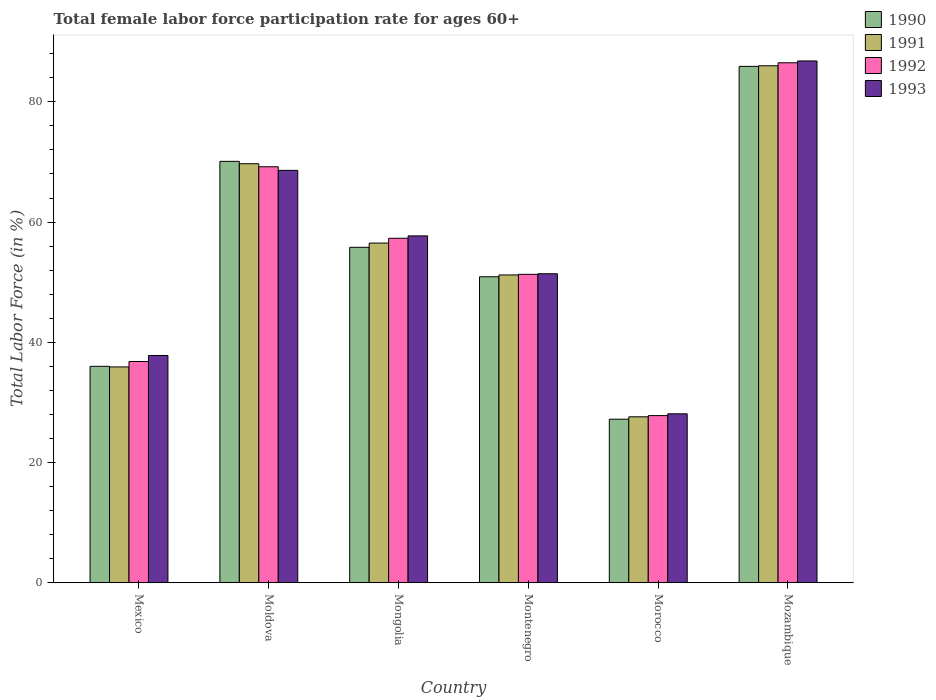How many different coloured bars are there?
Provide a succinct answer. 4. How many groups of bars are there?
Your answer should be very brief. 6. How many bars are there on the 5th tick from the left?
Keep it short and to the point. 4. What is the label of the 4th group of bars from the left?
Give a very brief answer. Montenegro. In how many cases, is the number of bars for a given country not equal to the number of legend labels?
Provide a short and direct response. 0. What is the female labor force participation rate in 1992 in Morocco?
Provide a succinct answer. 27.8. Across all countries, what is the maximum female labor force participation rate in 1990?
Your answer should be compact. 85.9. Across all countries, what is the minimum female labor force participation rate in 1990?
Provide a succinct answer. 27.2. In which country was the female labor force participation rate in 1991 maximum?
Offer a terse response. Mozambique. In which country was the female labor force participation rate in 1990 minimum?
Keep it short and to the point. Morocco. What is the total female labor force participation rate in 1993 in the graph?
Your answer should be compact. 330.4. What is the difference between the female labor force participation rate in 1993 in Moldova and that in Mongolia?
Your answer should be very brief. 10.9. What is the difference between the female labor force participation rate in 1990 in Mongolia and the female labor force participation rate in 1992 in Morocco?
Your answer should be compact. 28. What is the average female labor force participation rate in 1993 per country?
Ensure brevity in your answer.  55.07. What is the difference between the female labor force participation rate of/in 1993 and female labor force participation rate of/in 1991 in Mozambique?
Ensure brevity in your answer.  0.8. In how many countries, is the female labor force participation rate in 1993 greater than 8 %?
Offer a very short reply. 6. What is the ratio of the female labor force participation rate in 1990 in Mexico to that in Moldova?
Make the answer very short. 0.51. What is the difference between the highest and the second highest female labor force participation rate in 1990?
Provide a short and direct response. 15.8. What is the difference between the highest and the lowest female labor force participation rate in 1991?
Your answer should be compact. 58.4. Is the sum of the female labor force participation rate in 1993 in Mexico and Montenegro greater than the maximum female labor force participation rate in 1990 across all countries?
Your response must be concise. Yes. Is it the case that in every country, the sum of the female labor force participation rate in 1992 and female labor force participation rate in 1993 is greater than the sum of female labor force participation rate in 1990 and female labor force participation rate in 1991?
Provide a short and direct response. No. What does the 1st bar from the right in Montenegro represents?
Provide a short and direct response. 1993. How many bars are there?
Offer a terse response. 24. How many countries are there in the graph?
Keep it short and to the point. 6. What is the difference between two consecutive major ticks on the Y-axis?
Your response must be concise. 20. Are the values on the major ticks of Y-axis written in scientific E-notation?
Keep it short and to the point. No. Does the graph contain any zero values?
Offer a very short reply. No. How many legend labels are there?
Your answer should be compact. 4. How are the legend labels stacked?
Give a very brief answer. Vertical. What is the title of the graph?
Ensure brevity in your answer.  Total female labor force participation rate for ages 60+. Does "1975" appear as one of the legend labels in the graph?
Give a very brief answer. No. What is the Total Labor Force (in %) of 1991 in Mexico?
Your answer should be very brief. 35.9. What is the Total Labor Force (in %) in 1992 in Mexico?
Your answer should be compact. 36.8. What is the Total Labor Force (in %) in 1993 in Mexico?
Provide a succinct answer. 37.8. What is the Total Labor Force (in %) of 1990 in Moldova?
Provide a succinct answer. 70.1. What is the Total Labor Force (in %) in 1991 in Moldova?
Ensure brevity in your answer.  69.7. What is the Total Labor Force (in %) in 1992 in Moldova?
Give a very brief answer. 69.2. What is the Total Labor Force (in %) of 1993 in Moldova?
Your answer should be very brief. 68.6. What is the Total Labor Force (in %) in 1990 in Mongolia?
Your answer should be compact. 55.8. What is the Total Labor Force (in %) of 1991 in Mongolia?
Offer a very short reply. 56.5. What is the Total Labor Force (in %) of 1992 in Mongolia?
Provide a short and direct response. 57.3. What is the Total Labor Force (in %) of 1993 in Mongolia?
Provide a short and direct response. 57.7. What is the Total Labor Force (in %) in 1990 in Montenegro?
Ensure brevity in your answer.  50.9. What is the Total Labor Force (in %) of 1991 in Montenegro?
Your answer should be very brief. 51.2. What is the Total Labor Force (in %) in 1992 in Montenegro?
Make the answer very short. 51.3. What is the Total Labor Force (in %) of 1993 in Montenegro?
Give a very brief answer. 51.4. What is the Total Labor Force (in %) of 1990 in Morocco?
Your answer should be compact. 27.2. What is the Total Labor Force (in %) in 1991 in Morocco?
Your answer should be very brief. 27.6. What is the Total Labor Force (in %) in 1992 in Morocco?
Provide a succinct answer. 27.8. What is the Total Labor Force (in %) of 1993 in Morocco?
Offer a terse response. 28.1. What is the Total Labor Force (in %) in 1990 in Mozambique?
Provide a succinct answer. 85.9. What is the Total Labor Force (in %) in 1991 in Mozambique?
Your answer should be very brief. 86. What is the Total Labor Force (in %) of 1992 in Mozambique?
Offer a very short reply. 86.5. What is the Total Labor Force (in %) of 1993 in Mozambique?
Your response must be concise. 86.8. Across all countries, what is the maximum Total Labor Force (in %) in 1990?
Ensure brevity in your answer.  85.9. Across all countries, what is the maximum Total Labor Force (in %) of 1992?
Keep it short and to the point. 86.5. Across all countries, what is the maximum Total Labor Force (in %) in 1993?
Provide a short and direct response. 86.8. Across all countries, what is the minimum Total Labor Force (in %) of 1990?
Ensure brevity in your answer.  27.2. Across all countries, what is the minimum Total Labor Force (in %) in 1991?
Offer a terse response. 27.6. Across all countries, what is the minimum Total Labor Force (in %) of 1992?
Your answer should be very brief. 27.8. Across all countries, what is the minimum Total Labor Force (in %) of 1993?
Your response must be concise. 28.1. What is the total Total Labor Force (in %) in 1990 in the graph?
Your answer should be compact. 325.9. What is the total Total Labor Force (in %) in 1991 in the graph?
Provide a succinct answer. 326.9. What is the total Total Labor Force (in %) of 1992 in the graph?
Provide a succinct answer. 328.9. What is the total Total Labor Force (in %) of 1993 in the graph?
Offer a very short reply. 330.4. What is the difference between the Total Labor Force (in %) in 1990 in Mexico and that in Moldova?
Offer a very short reply. -34.1. What is the difference between the Total Labor Force (in %) in 1991 in Mexico and that in Moldova?
Offer a terse response. -33.8. What is the difference between the Total Labor Force (in %) in 1992 in Mexico and that in Moldova?
Provide a short and direct response. -32.4. What is the difference between the Total Labor Force (in %) in 1993 in Mexico and that in Moldova?
Provide a short and direct response. -30.8. What is the difference between the Total Labor Force (in %) of 1990 in Mexico and that in Mongolia?
Offer a very short reply. -19.8. What is the difference between the Total Labor Force (in %) in 1991 in Mexico and that in Mongolia?
Ensure brevity in your answer.  -20.6. What is the difference between the Total Labor Force (in %) in 1992 in Mexico and that in Mongolia?
Ensure brevity in your answer.  -20.5. What is the difference between the Total Labor Force (in %) in 1993 in Mexico and that in Mongolia?
Provide a succinct answer. -19.9. What is the difference between the Total Labor Force (in %) of 1990 in Mexico and that in Montenegro?
Your answer should be compact. -14.9. What is the difference between the Total Labor Force (in %) in 1991 in Mexico and that in Montenegro?
Your answer should be compact. -15.3. What is the difference between the Total Labor Force (in %) of 1993 in Mexico and that in Montenegro?
Your answer should be compact. -13.6. What is the difference between the Total Labor Force (in %) in 1990 in Mexico and that in Morocco?
Offer a terse response. 8.8. What is the difference between the Total Labor Force (in %) of 1991 in Mexico and that in Morocco?
Provide a succinct answer. 8.3. What is the difference between the Total Labor Force (in %) of 1992 in Mexico and that in Morocco?
Your answer should be very brief. 9. What is the difference between the Total Labor Force (in %) in 1990 in Mexico and that in Mozambique?
Provide a short and direct response. -49.9. What is the difference between the Total Labor Force (in %) of 1991 in Mexico and that in Mozambique?
Your answer should be compact. -50.1. What is the difference between the Total Labor Force (in %) of 1992 in Mexico and that in Mozambique?
Offer a very short reply. -49.7. What is the difference between the Total Labor Force (in %) in 1993 in Mexico and that in Mozambique?
Your response must be concise. -49. What is the difference between the Total Labor Force (in %) of 1990 in Moldova and that in Mongolia?
Give a very brief answer. 14.3. What is the difference between the Total Labor Force (in %) of 1991 in Moldova and that in Mongolia?
Make the answer very short. 13.2. What is the difference between the Total Labor Force (in %) in 1992 in Moldova and that in Mongolia?
Your answer should be very brief. 11.9. What is the difference between the Total Labor Force (in %) in 1990 in Moldova and that in Montenegro?
Your answer should be compact. 19.2. What is the difference between the Total Labor Force (in %) in 1993 in Moldova and that in Montenegro?
Provide a short and direct response. 17.2. What is the difference between the Total Labor Force (in %) of 1990 in Moldova and that in Morocco?
Your response must be concise. 42.9. What is the difference between the Total Labor Force (in %) in 1991 in Moldova and that in Morocco?
Give a very brief answer. 42.1. What is the difference between the Total Labor Force (in %) in 1992 in Moldova and that in Morocco?
Your answer should be compact. 41.4. What is the difference between the Total Labor Force (in %) in 1993 in Moldova and that in Morocco?
Your response must be concise. 40.5. What is the difference between the Total Labor Force (in %) of 1990 in Moldova and that in Mozambique?
Provide a short and direct response. -15.8. What is the difference between the Total Labor Force (in %) of 1991 in Moldova and that in Mozambique?
Offer a very short reply. -16.3. What is the difference between the Total Labor Force (in %) of 1992 in Moldova and that in Mozambique?
Make the answer very short. -17.3. What is the difference between the Total Labor Force (in %) of 1993 in Moldova and that in Mozambique?
Your answer should be compact. -18.2. What is the difference between the Total Labor Force (in %) of 1990 in Mongolia and that in Montenegro?
Your answer should be compact. 4.9. What is the difference between the Total Labor Force (in %) in 1991 in Mongolia and that in Montenegro?
Offer a very short reply. 5.3. What is the difference between the Total Labor Force (in %) of 1993 in Mongolia and that in Montenegro?
Keep it short and to the point. 6.3. What is the difference between the Total Labor Force (in %) of 1990 in Mongolia and that in Morocco?
Ensure brevity in your answer.  28.6. What is the difference between the Total Labor Force (in %) in 1991 in Mongolia and that in Morocco?
Ensure brevity in your answer.  28.9. What is the difference between the Total Labor Force (in %) in 1992 in Mongolia and that in Morocco?
Give a very brief answer. 29.5. What is the difference between the Total Labor Force (in %) of 1993 in Mongolia and that in Morocco?
Your response must be concise. 29.6. What is the difference between the Total Labor Force (in %) in 1990 in Mongolia and that in Mozambique?
Provide a short and direct response. -30.1. What is the difference between the Total Labor Force (in %) of 1991 in Mongolia and that in Mozambique?
Your answer should be compact. -29.5. What is the difference between the Total Labor Force (in %) of 1992 in Mongolia and that in Mozambique?
Your response must be concise. -29.2. What is the difference between the Total Labor Force (in %) of 1993 in Mongolia and that in Mozambique?
Ensure brevity in your answer.  -29.1. What is the difference between the Total Labor Force (in %) of 1990 in Montenegro and that in Morocco?
Your answer should be compact. 23.7. What is the difference between the Total Labor Force (in %) in 1991 in Montenegro and that in Morocco?
Your answer should be very brief. 23.6. What is the difference between the Total Labor Force (in %) in 1992 in Montenegro and that in Morocco?
Offer a very short reply. 23.5. What is the difference between the Total Labor Force (in %) of 1993 in Montenegro and that in Morocco?
Offer a very short reply. 23.3. What is the difference between the Total Labor Force (in %) of 1990 in Montenegro and that in Mozambique?
Ensure brevity in your answer.  -35. What is the difference between the Total Labor Force (in %) of 1991 in Montenegro and that in Mozambique?
Your answer should be compact. -34.8. What is the difference between the Total Labor Force (in %) in 1992 in Montenegro and that in Mozambique?
Give a very brief answer. -35.2. What is the difference between the Total Labor Force (in %) of 1993 in Montenegro and that in Mozambique?
Make the answer very short. -35.4. What is the difference between the Total Labor Force (in %) of 1990 in Morocco and that in Mozambique?
Keep it short and to the point. -58.7. What is the difference between the Total Labor Force (in %) of 1991 in Morocco and that in Mozambique?
Give a very brief answer. -58.4. What is the difference between the Total Labor Force (in %) of 1992 in Morocco and that in Mozambique?
Provide a succinct answer. -58.7. What is the difference between the Total Labor Force (in %) in 1993 in Morocco and that in Mozambique?
Provide a short and direct response. -58.7. What is the difference between the Total Labor Force (in %) of 1990 in Mexico and the Total Labor Force (in %) of 1991 in Moldova?
Keep it short and to the point. -33.7. What is the difference between the Total Labor Force (in %) in 1990 in Mexico and the Total Labor Force (in %) in 1992 in Moldova?
Your answer should be compact. -33.2. What is the difference between the Total Labor Force (in %) of 1990 in Mexico and the Total Labor Force (in %) of 1993 in Moldova?
Provide a short and direct response. -32.6. What is the difference between the Total Labor Force (in %) in 1991 in Mexico and the Total Labor Force (in %) in 1992 in Moldova?
Provide a short and direct response. -33.3. What is the difference between the Total Labor Force (in %) of 1991 in Mexico and the Total Labor Force (in %) of 1993 in Moldova?
Offer a terse response. -32.7. What is the difference between the Total Labor Force (in %) in 1992 in Mexico and the Total Labor Force (in %) in 1993 in Moldova?
Provide a succinct answer. -31.8. What is the difference between the Total Labor Force (in %) in 1990 in Mexico and the Total Labor Force (in %) in 1991 in Mongolia?
Provide a short and direct response. -20.5. What is the difference between the Total Labor Force (in %) of 1990 in Mexico and the Total Labor Force (in %) of 1992 in Mongolia?
Provide a succinct answer. -21.3. What is the difference between the Total Labor Force (in %) of 1990 in Mexico and the Total Labor Force (in %) of 1993 in Mongolia?
Your answer should be very brief. -21.7. What is the difference between the Total Labor Force (in %) in 1991 in Mexico and the Total Labor Force (in %) in 1992 in Mongolia?
Offer a terse response. -21.4. What is the difference between the Total Labor Force (in %) in 1991 in Mexico and the Total Labor Force (in %) in 1993 in Mongolia?
Give a very brief answer. -21.8. What is the difference between the Total Labor Force (in %) of 1992 in Mexico and the Total Labor Force (in %) of 1993 in Mongolia?
Ensure brevity in your answer.  -20.9. What is the difference between the Total Labor Force (in %) in 1990 in Mexico and the Total Labor Force (in %) in 1991 in Montenegro?
Offer a terse response. -15.2. What is the difference between the Total Labor Force (in %) of 1990 in Mexico and the Total Labor Force (in %) of 1992 in Montenegro?
Make the answer very short. -15.3. What is the difference between the Total Labor Force (in %) in 1990 in Mexico and the Total Labor Force (in %) in 1993 in Montenegro?
Offer a very short reply. -15.4. What is the difference between the Total Labor Force (in %) in 1991 in Mexico and the Total Labor Force (in %) in 1992 in Montenegro?
Provide a short and direct response. -15.4. What is the difference between the Total Labor Force (in %) in 1991 in Mexico and the Total Labor Force (in %) in 1993 in Montenegro?
Provide a short and direct response. -15.5. What is the difference between the Total Labor Force (in %) of 1992 in Mexico and the Total Labor Force (in %) of 1993 in Montenegro?
Offer a very short reply. -14.6. What is the difference between the Total Labor Force (in %) in 1990 in Mexico and the Total Labor Force (in %) in 1993 in Morocco?
Provide a short and direct response. 7.9. What is the difference between the Total Labor Force (in %) of 1992 in Mexico and the Total Labor Force (in %) of 1993 in Morocco?
Provide a succinct answer. 8.7. What is the difference between the Total Labor Force (in %) of 1990 in Mexico and the Total Labor Force (in %) of 1991 in Mozambique?
Ensure brevity in your answer.  -50. What is the difference between the Total Labor Force (in %) of 1990 in Mexico and the Total Labor Force (in %) of 1992 in Mozambique?
Provide a short and direct response. -50.5. What is the difference between the Total Labor Force (in %) in 1990 in Mexico and the Total Labor Force (in %) in 1993 in Mozambique?
Ensure brevity in your answer.  -50.8. What is the difference between the Total Labor Force (in %) in 1991 in Mexico and the Total Labor Force (in %) in 1992 in Mozambique?
Your response must be concise. -50.6. What is the difference between the Total Labor Force (in %) of 1991 in Mexico and the Total Labor Force (in %) of 1993 in Mozambique?
Give a very brief answer. -50.9. What is the difference between the Total Labor Force (in %) of 1991 in Moldova and the Total Labor Force (in %) of 1992 in Mongolia?
Keep it short and to the point. 12.4. What is the difference between the Total Labor Force (in %) in 1990 in Moldova and the Total Labor Force (in %) in 1992 in Montenegro?
Your response must be concise. 18.8. What is the difference between the Total Labor Force (in %) of 1990 in Moldova and the Total Labor Force (in %) of 1993 in Montenegro?
Your answer should be very brief. 18.7. What is the difference between the Total Labor Force (in %) in 1990 in Moldova and the Total Labor Force (in %) in 1991 in Morocco?
Give a very brief answer. 42.5. What is the difference between the Total Labor Force (in %) in 1990 in Moldova and the Total Labor Force (in %) in 1992 in Morocco?
Give a very brief answer. 42.3. What is the difference between the Total Labor Force (in %) of 1991 in Moldova and the Total Labor Force (in %) of 1992 in Morocco?
Provide a short and direct response. 41.9. What is the difference between the Total Labor Force (in %) of 1991 in Moldova and the Total Labor Force (in %) of 1993 in Morocco?
Make the answer very short. 41.6. What is the difference between the Total Labor Force (in %) of 1992 in Moldova and the Total Labor Force (in %) of 1993 in Morocco?
Ensure brevity in your answer.  41.1. What is the difference between the Total Labor Force (in %) in 1990 in Moldova and the Total Labor Force (in %) in 1991 in Mozambique?
Your answer should be compact. -15.9. What is the difference between the Total Labor Force (in %) in 1990 in Moldova and the Total Labor Force (in %) in 1992 in Mozambique?
Provide a short and direct response. -16.4. What is the difference between the Total Labor Force (in %) of 1990 in Moldova and the Total Labor Force (in %) of 1993 in Mozambique?
Provide a short and direct response. -16.7. What is the difference between the Total Labor Force (in %) in 1991 in Moldova and the Total Labor Force (in %) in 1992 in Mozambique?
Your answer should be compact. -16.8. What is the difference between the Total Labor Force (in %) in 1991 in Moldova and the Total Labor Force (in %) in 1993 in Mozambique?
Offer a terse response. -17.1. What is the difference between the Total Labor Force (in %) in 1992 in Moldova and the Total Labor Force (in %) in 1993 in Mozambique?
Provide a succinct answer. -17.6. What is the difference between the Total Labor Force (in %) of 1990 in Mongolia and the Total Labor Force (in %) of 1992 in Montenegro?
Provide a short and direct response. 4.5. What is the difference between the Total Labor Force (in %) in 1991 in Mongolia and the Total Labor Force (in %) in 1993 in Montenegro?
Provide a short and direct response. 5.1. What is the difference between the Total Labor Force (in %) in 1990 in Mongolia and the Total Labor Force (in %) in 1991 in Morocco?
Ensure brevity in your answer.  28.2. What is the difference between the Total Labor Force (in %) of 1990 in Mongolia and the Total Labor Force (in %) of 1992 in Morocco?
Offer a terse response. 28. What is the difference between the Total Labor Force (in %) in 1990 in Mongolia and the Total Labor Force (in %) in 1993 in Morocco?
Keep it short and to the point. 27.7. What is the difference between the Total Labor Force (in %) in 1991 in Mongolia and the Total Labor Force (in %) in 1992 in Morocco?
Provide a succinct answer. 28.7. What is the difference between the Total Labor Force (in %) in 1991 in Mongolia and the Total Labor Force (in %) in 1993 in Morocco?
Keep it short and to the point. 28.4. What is the difference between the Total Labor Force (in %) in 1992 in Mongolia and the Total Labor Force (in %) in 1993 in Morocco?
Ensure brevity in your answer.  29.2. What is the difference between the Total Labor Force (in %) of 1990 in Mongolia and the Total Labor Force (in %) of 1991 in Mozambique?
Ensure brevity in your answer.  -30.2. What is the difference between the Total Labor Force (in %) in 1990 in Mongolia and the Total Labor Force (in %) in 1992 in Mozambique?
Keep it short and to the point. -30.7. What is the difference between the Total Labor Force (in %) in 1990 in Mongolia and the Total Labor Force (in %) in 1993 in Mozambique?
Provide a succinct answer. -31. What is the difference between the Total Labor Force (in %) in 1991 in Mongolia and the Total Labor Force (in %) in 1992 in Mozambique?
Provide a short and direct response. -30. What is the difference between the Total Labor Force (in %) of 1991 in Mongolia and the Total Labor Force (in %) of 1993 in Mozambique?
Your response must be concise. -30.3. What is the difference between the Total Labor Force (in %) of 1992 in Mongolia and the Total Labor Force (in %) of 1993 in Mozambique?
Ensure brevity in your answer.  -29.5. What is the difference between the Total Labor Force (in %) in 1990 in Montenegro and the Total Labor Force (in %) in 1991 in Morocco?
Your answer should be very brief. 23.3. What is the difference between the Total Labor Force (in %) in 1990 in Montenegro and the Total Labor Force (in %) in 1992 in Morocco?
Provide a succinct answer. 23.1. What is the difference between the Total Labor Force (in %) of 1990 in Montenegro and the Total Labor Force (in %) of 1993 in Morocco?
Your answer should be compact. 22.8. What is the difference between the Total Labor Force (in %) of 1991 in Montenegro and the Total Labor Force (in %) of 1992 in Morocco?
Your answer should be compact. 23.4. What is the difference between the Total Labor Force (in %) of 1991 in Montenegro and the Total Labor Force (in %) of 1993 in Morocco?
Keep it short and to the point. 23.1. What is the difference between the Total Labor Force (in %) of 1992 in Montenegro and the Total Labor Force (in %) of 1993 in Morocco?
Offer a very short reply. 23.2. What is the difference between the Total Labor Force (in %) of 1990 in Montenegro and the Total Labor Force (in %) of 1991 in Mozambique?
Provide a succinct answer. -35.1. What is the difference between the Total Labor Force (in %) in 1990 in Montenegro and the Total Labor Force (in %) in 1992 in Mozambique?
Your response must be concise. -35.6. What is the difference between the Total Labor Force (in %) in 1990 in Montenegro and the Total Labor Force (in %) in 1993 in Mozambique?
Offer a terse response. -35.9. What is the difference between the Total Labor Force (in %) of 1991 in Montenegro and the Total Labor Force (in %) of 1992 in Mozambique?
Provide a succinct answer. -35.3. What is the difference between the Total Labor Force (in %) in 1991 in Montenegro and the Total Labor Force (in %) in 1993 in Mozambique?
Offer a very short reply. -35.6. What is the difference between the Total Labor Force (in %) of 1992 in Montenegro and the Total Labor Force (in %) of 1993 in Mozambique?
Provide a short and direct response. -35.5. What is the difference between the Total Labor Force (in %) of 1990 in Morocco and the Total Labor Force (in %) of 1991 in Mozambique?
Offer a very short reply. -58.8. What is the difference between the Total Labor Force (in %) of 1990 in Morocco and the Total Labor Force (in %) of 1992 in Mozambique?
Ensure brevity in your answer.  -59.3. What is the difference between the Total Labor Force (in %) in 1990 in Morocco and the Total Labor Force (in %) in 1993 in Mozambique?
Your answer should be very brief. -59.6. What is the difference between the Total Labor Force (in %) in 1991 in Morocco and the Total Labor Force (in %) in 1992 in Mozambique?
Give a very brief answer. -58.9. What is the difference between the Total Labor Force (in %) in 1991 in Morocco and the Total Labor Force (in %) in 1993 in Mozambique?
Give a very brief answer. -59.2. What is the difference between the Total Labor Force (in %) of 1992 in Morocco and the Total Labor Force (in %) of 1993 in Mozambique?
Give a very brief answer. -59. What is the average Total Labor Force (in %) in 1990 per country?
Provide a short and direct response. 54.32. What is the average Total Labor Force (in %) in 1991 per country?
Your answer should be compact. 54.48. What is the average Total Labor Force (in %) of 1992 per country?
Provide a short and direct response. 54.82. What is the average Total Labor Force (in %) in 1993 per country?
Provide a short and direct response. 55.07. What is the difference between the Total Labor Force (in %) in 1990 and Total Labor Force (in %) in 1992 in Mexico?
Your answer should be compact. -0.8. What is the difference between the Total Labor Force (in %) in 1990 and Total Labor Force (in %) in 1993 in Mexico?
Give a very brief answer. -1.8. What is the difference between the Total Labor Force (in %) of 1991 and Total Labor Force (in %) of 1992 in Mexico?
Give a very brief answer. -0.9. What is the difference between the Total Labor Force (in %) of 1990 and Total Labor Force (in %) of 1992 in Moldova?
Your answer should be very brief. 0.9. What is the difference between the Total Labor Force (in %) in 1990 and Total Labor Force (in %) in 1993 in Moldova?
Provide a succinct answer. 1.5. What is the difference between the Total Labor Force (in %) of 1991 and Total Labor Force (in %) of 1993 in Moldova?
Keep it short and to the point. 1.1. What is the difference between the Total Labor Force (in %) in 1992 and Total Labor Force (in %) in 1993 in Moldova?
Your answer should be very brief. 0.6. What is the difference between the Total Labor Force (in %) in 1990 and Total Labor Force (in %) in 1992 in Mongolia?
Give a very brief answer. -1.5. What is the difference between the Total Labor Force (in %) in 1990 and Total Labor Force (in %) in 1993 in Mongolia?
Keep it short and to the point. -1.9. What is the difference between the Total Labor Force (in %) in 1990 and Total Labor Force (in %) in 1991 in Montenegro?
Provide a short and direct response. -0.3. What is the difference between the Total Labor Force (in %) in 1990 and Total Labor Force (in %) in 1992 in Montenegro?
Give a very brief answer. -0.4. What is the difference between the Total Labor Force (in %) in 1990 and Total Labor Force (in %) in 1991 in Morocco?
Your response must be concise. -0.4. What is the difference between the Total Labor Force (in %) of 1990 and Total Labor Force (in %) of 1992 in Morocco?
Ensure brevity in your answer.  -0.6. What is the difference between the Total Labor Force (in %) in 1990 and Total Labor Force (in %) in 1993 in Morocco?
Provide a succinct answer. -0.9. What is the difference between the Total Labor Force (in %) of 1991 and Total Labor Force (in %) of 1993 in Morocco?
Make the answer very short. -0.5. What is the difference between the Total Labor Force (in %) of 1990 and Total Labor Force (in %) of 1992 in Mozambique?
Give a very brief answer. -0.6. What is the difference between the Total Labor Force (in %) in 1990 and Total Labor Force (in %) in 1993 in Mozambique?
Ensure brevity in your answer.  -0.9. What is the ratio of the Total Labor Force (in %) of 1990 in Mexico to that in Moldova?
Provide a short and direct response. 0.51. What is the ratio of the Total Labor Force (in %) of 1991 in Mexico to that in Moldova?
Make the answer very short. 0.52. What is the ratio of the Total Labor Force (in %) in 1992 in Mexico to that in Moldova?
Your answer should be compact. 0.53. What is the ratio of the Total Labor Force (in %) in 1993 in Mexico to that in Moldova?
Make the answer very short. 0.55. What is the ratio of the Total Labor Force (in %) of 1990 in Mexico to that in Mongolia?
Offer a terse response. 0.65. What is the ratio of the Total Labor Force (in %) in 1991 in Mexico to that in Mongolia?
Provide a short and direct response. 0.64. What is the ratio of the Total Labor Force (in %) in 1992 in Mexico to that in Mongolia?
Provide a succinct answer. 0.64. What is the ratio of the Total Labor Force (in %) in 1993 in Mexico to that in Mongolia?
Keep it short and to the point. 0.66. What is the ratio of the Total Labor Force (in %) in 1990 in Mexico to that in Montenegro?
Give a very brief answer. 0.71. What is the ratio of the Total Labor Force (in %) in 1991 in Mexico to that in Montenegro?
Make the answer very short. 0.7. What is the ratio of the Total Labor Force (in %) in 1992 in Mexico to that in Montenegro?
Your answer should be very brief. 0.72. What is the ratio of the Total Labor Force (in %) of 1993 in Mexico to that in Montenegro?
Offer a very short reply. 0.74. What is the ratio of the Total Labor Force (in %) of 1990 in Mexico to that in Morocco?
Your response must be concise. 1.32. What is the ratio of the Total Labor Force (in %) of 1991 in Mexico to that in Morocco?
Your response must be concise. 1.3. What is the ratio of the Total Labor Force (in %) in 1992 in Mexico to that in Morocco?
Keep it short and to the point. 1.32. What is the ratio of the Total Labor Force (in %) of 1993 in Mexico to that in Morocco?
Provide a short and direct response. 1.35. What is the ratio of the Total Labor Force (in %) in 1990 in Mexico to that in Mozambique?
Your answer should be very brief. 0.42. What is the ratio of the Total Labor Force (in %) of 1991 in Mexico to that in Mozambique?
Your answer should be very brief. 0.42. What is the ratio of the Total Labor Force (in %) in 1992 in Mexico to that in Mozambique?
Keep it short and to the point. 0.43. What is the ratio of the Total Labor Force (in %) in 1993 in Mexico to that in Mozambique?
Offer a terse response. 0.44. What is the ratio of the Total Labor Force (in %) of 1990 in Moldova to that in Mongolia?
Provide a short and direct response. 1.26. What is the ratio of the Total Labor Force (in %) in 1991 in Moldova to that in Mongolia?
Make the answer very short. 1.23. What is the ratio of the Total Labor Force (in %) of 1992 in Moldova to that in Mongolia?
Ensure brevity in your answer.  1.21. What is the ratio of the Total Labor Force (in %) of 1993 in Moldova to that in Mongolia?
Offer a terse response. 1.19. What is the ratio of the Total Labor Force (in %) in 1990 in Moldova to that in Montenegro?
Make the answer very short. 1.38. What is the ratio of the Total Labor Force (in %) of 1991 in Moldova to that in Montenegro?
Your answer should be compact. 1.36. What is the ratio of the Total Labor Force (in %) of 1992 in Moldova to that in Montenegro?
Ensure brevity in your answer.  1.35. What is the ratio of the Total Labor Force (in %) of 1993 in Moldova to that in Montenegro?
Offer a very short reply. 1.33. What is the ratio of the Total Labor Force (in %) of 1990 in Moldova to that in Morocco?
Offer a very short reply. 2.58. What is the ratio of the Total Labor Force (in %) in 1991 in Moldova to that in Morocco?
Your answer should be very brief. 2.53. What is the ratio of the Total Labor Force (in %) of 1992 in Moldova to that in Morocco?
Your answer should be compact. 2.49. What is the ratio of the Total Labor Force (in %) of 1993 in Moldova to that in Morocco?
Your response must be concise. 2.44. What is the ratio of the Total Labor Force (in %) of 1990 in Moldova to that in Mozambique?
Provide a short and direct response. 0.82. What is the ratio of the Total Labor Force (in %) in 1991 in Moldova to that in Mozambique?
Provide a short and direct response. 0.81. What is the ratio of the Total Labor Force (in %) in 1993 in Moldova to that in Mozambique?
Provide a short and direct response. 0.79. What is the ratio of the Total Labor Force (in %) in 1990 in Mongolia to that in Montenegro?
Offer a terse response. 1.1. What is the ratio of the Total Labor Force (in %) of 1991 in Mongolia to that in Montenegro?
Keep it short and to the point. 1.1. What is the ratio of the Total Labor Force (in %) in 1992 in Mongolia to that in Montenegro?
Your response must be concise. 1.12. What is the ratio of the Total Labor Force (in %) of 1993 in Mongolia to that in Montenegro?
Offer a very short reply. 1.12. What is the ratio of the Total Labor Force (in %) of 1990 in Mongolia to that in Morocco?
Provide a succinct answer. 2.05. What is the ratio of the Total Labor Force (in %) in 1991 in Mongolia to that in Morocco?
Provide a succinct answer. 2.05. What is the ratio of the Total Labor Force (in %) in 1992 in Mongolia to that in Morocco?
Your response must be concise. 2.06. What is the ratio of the Total Labor Force (in %) of 1993 in Mongolia to that in Morocco?
Offer a very short reply. 2.05. What is the ratio of the Total Labor Force (in %) in 1990 in Mongolia to that in Mozambique?
Provide a succinct answer. 0.65. What is the ratio of the Total Labor Force (in %) in 1991 in Mongolia to that in Mozambique?
Give a very brief answer. 0.66. What is the ratio of the Total Labor Force (in %) in 1992 in Mongolia to that in Mozambique?
Your answer should be compact. 0.66. What is the ratio of the Total Labor Force (in %) of 1993 in Mongolia to that in Mozambique?
Make the answer very short. 0.66. What is the ratio of the Total Labor Force (in %) of 1990 in Montenegro to that in Morocco?
Your answer should be compact. 1.87. What is the ratio of the Total Labor Force (in %) in 1991 in Montenegro to that in Morocco?
Give a very brief answer. 1.86. What is the ratio of the Total Labor Force (in %) in 1992 in Montenegro to that in Morocco?
Give a very brief answer. 1.85. What is the ratio of the Total Labor Force (in %) of 1993 in Montenegro to that in Morocco?
Your response must be concise. 1.83. What is the ratio of the Total Labor Force (in %) in 1990 in Montenegro to that in Mozambique?
Provide a succinct answer. 0.59. What is the ratio of the Total Labor Force (in %) of 1991 in Montenegro to that in Mozambique?
Your response must be concise. 0.6. What is the ratio of the Total Labor Force (in %) of 1992 in Montenegro to that in Mozambique?
Provide a succinct answer. 0.59. What is the ratio of the Total Labor Force (in %) of 1993 in Montenegro to that in Mozambique?
Your answer should be very brief. 0.59. What is the ratio of the Total Labor Force (in %) of 1990 in Morocco to that in Mozambique?
Your response must be concise. 0.32. What is the ratio of the Total Labor Force (in %) of 1991 in Morocco to that in Mozambique?
Ensure brevity in your answer.  0.32. What is the ratio of the Total Labor Force (in %) in 1992 in Morocco to that in Mozambique?
Keep it short and to the point. 0.32. What is the ratio of the Total Labor Force (in %) of 1993 in Morocco to that in Mozambique?
Keep it short and to the point. 0.32. What is the difference between the highest and the second highest Total Labor Force (in %) in 1992?
Make the answer very short. 17.3. What is the difference between the highest and the lowest Total Labor Force (in %) of 1990?
Keep it short and to the point. 58.7. What is the difference between the highest and the lowest Total Labor Force (in %) of 1991?
Offer a terse response. 58.4. What is the difference between the highest and the lowest Total Labor Force (in %) of 1992?
Your answer should be compact. 58.7. What is the difference between the highest and the lowest Total Labor Force (in %) of 1993?
Provide a succinct answer. 58.7. 